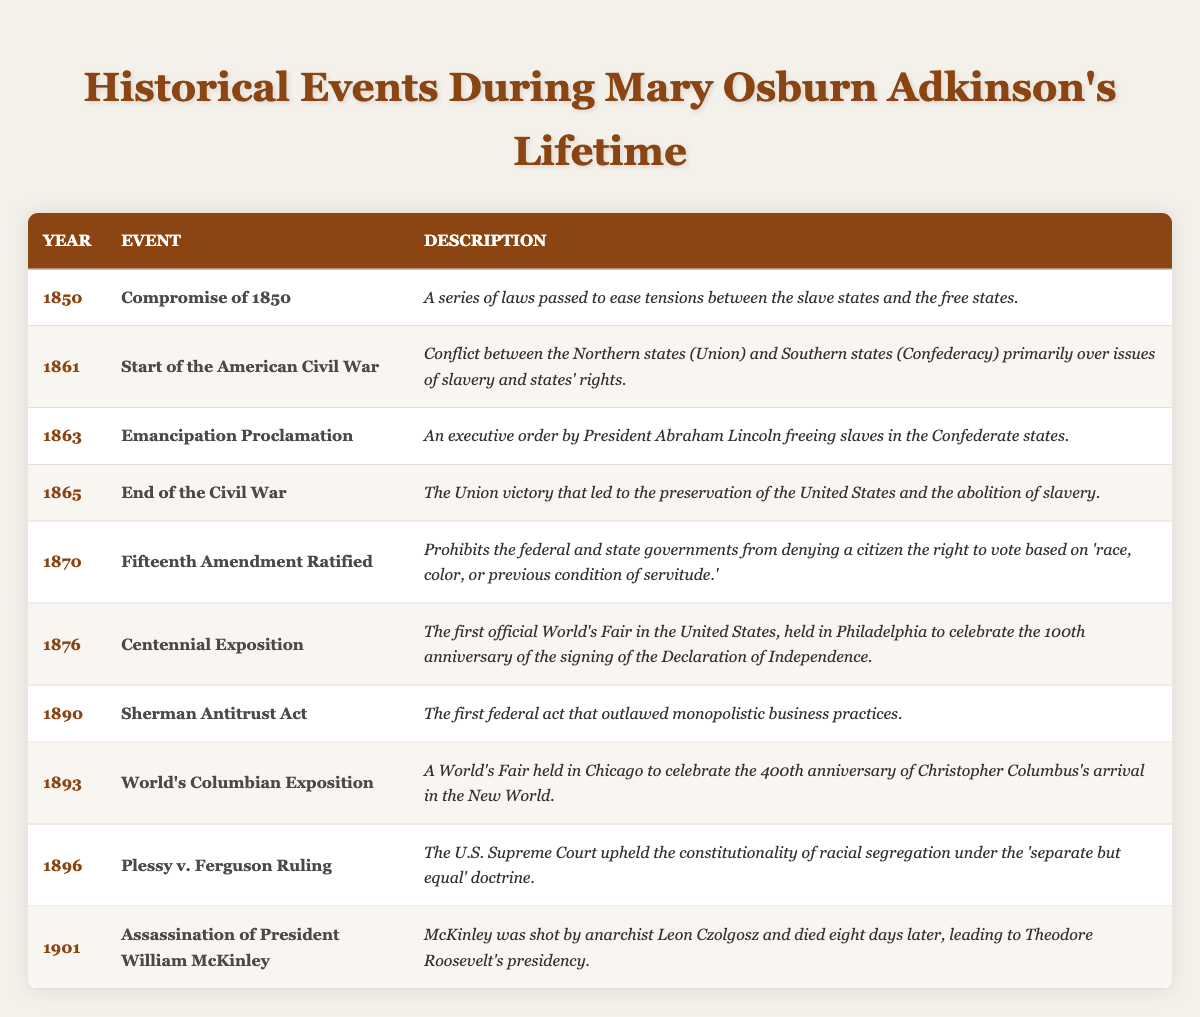What historical event occurred in **1863**? The table lists the events with their respective years. In 1863, the event noted is the **Emancipation Proclamation**.
Answer: Emancipation Proclamation How many years passed between the **Start of the American Civil War** in **1861** and the **End of the Civil War** in **1865**? To find the number of years between these two events, subtract the earlier year from the later year: 1865 - 1861 = 4 years.
Answer: 4 years Did the **Fifteenth Amendment** get ratified before or after the **Centennial Exposition**? The **Fifteenth Amendment was ratified in 1870**, and the **Centennial Exposition** took place in **1876**. Since 1870 is before 1876, the amendment was ratified before the exposition.
Answer: Before Which event in **1870** addressed voting rights? The **Fifteenth Amendment** is noted for being ratified in 1870, which prohibits denying voting rights based on race.
Answer: Fifteenth Amendment What significant legislative act was passed in **1890**? The table indicates that the **Sherman Antitrust Act** was enacted in 1890.
Answer: Sherman Antitrust Act In which year did the **World's Columbian Exposition** occur, and what was it celebrating? The **World's Columbian Exposition** occurred in 1893 and celebrated the 400th anniversary of Christopher Columbus's arrival in the New World.
Answer: 1893, Columbus's arrival List the events that occurred between **1861** and **1876**. The events in this range are: **Start of the American Civil War (1861)**, **Emancipation Proclamation (1863)**, **End of the Civil War (1865)**, **Fifteenth Amendment Ratified (1870)**, and **Centennial Exposition (1876)**.
Answer: 5 events How many events listed celebrated anniversaries, based on the table? The **Centennial Exposition** (1876) celebrated 100 years since the Declaration of Independence and the **World's Columbian Exposition** (1893) celebrated 400 years since Columbus's arrival, totaling two anniversary celebrations.
Answer: 2 events Was the **Assassination of President William McKinley** after the **Emancipation Proclamation**? The **Emancipation Proclamation** occurred in 1863, while McKinley's assassination was in 1901, making it after.
Answer: Yes How would you categorize the **Plessy v. Ferguson Ruling** in terms of its significance? The **Plessy v. Ferguson Ruling** in 1896 was significant as it upheld segregation laws under the "separate but equal" doctrine, impacting civil rights for years to come.
Answer: Significant civil rights case What can you infer about the relationship between the **End of the Civil War** and the legislative changes that followed? The **End of the Civil War** in 1865 likely facilitated significant legislative changes such as the **Fifteenth Amendment** in 1870, indicating a push toward civil rights for formerly enslaved populations.
Answer: Legislation aimed at civil rights followed the war 